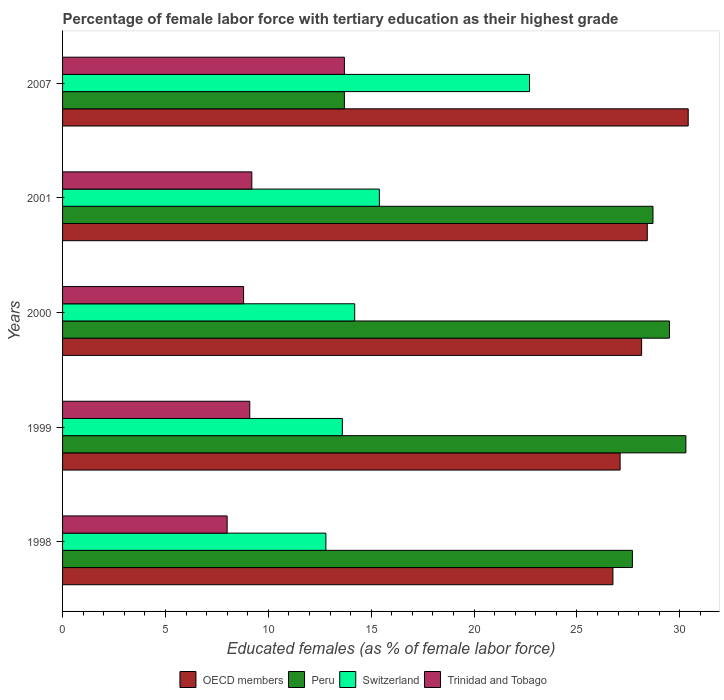How many different coloured bars are there?
Offer a very short reply. 4. How many groups of bars are there?
Give a very brief answer. 5. Are the number of bars per tick equal to the number of legend labels?
Your answer should be compact. Yes. How many bars are there on the 5th tick from the top?
Offer a terse response. 4. How many bars are there on the 3rd tick from the bottom?
Your response must be concise. 4. What is the label of the 2nd group of bars from the top?
Make the answer very short. 2001. What is the percentage of female labor force with tertiary education in Peru in 1998?
Provide a succinct answer. 27.7. Across all years, what is the maximum percentage of female labor force with tertiary education in OECD members?
Offer a very short reply. 30.41. Across all years, what is the minimum percentage of female labor force with tertiary education in Trinidad and Tobago?
Ensure brevity in your answer.  8. In which year was the percentage of female labor force with tertiary education in Peru maximum?
Ensure brevity in your answer.  1999. What is the total percentage of female labor force with tertiary education in Switzerland in the graph?
Make the answer very short. 78.7. What is the difference between the percentage of female labor force with tertiary education in Peru in 2000 and that in 2007?
Keep it short and to the point. 15.8. What is the difference between the percentage of female labor force with tertiary education in Peru in 1998 and the percentage of female labor force with tertiary education in Trinidad and Tobago in 2001?
Provide a succinct answer. 18.5. What is the average percentage of female labor force with tertiary education in Trinidad and Tobago per year?
Your response must be concise. 9.76. In the year 2007, what is the difference between the percentage of female labor force with tertiary education in Switzerland and percentage of female labor force with tertiary education in OECD members?
Provide a succinct answer. -7.71. What is the ratio of the percentage of female labor force with tertiary education in Switzerland in 1999 to that in 2007?
Keep it short and to the point. 0.6. Is the percentage of female labor force with tertiary education in Peru in 2000 less than that in 2001?
Make the answer very short. No. What is the difference between the highest and the second highest percentage of female labor force with tertiary education in Peru?
Provide a succinct answer. 0.8. What is the difference between the highest and the lowest percentage of female labor force with tertiary education in Trinidad and Tobago?
Offer a very short reply. 5.7. Is it the case that in every year, the sum of the percentage of female labor force with tertiary education in Trinidad and Tobago and percentage of female labor force with tertiary education in Switzerland is greater than the sum of percentage of female labor force with tertiary education in Peru and percentage of female labor force with tertiary education in OECD members?
Give a very brief answer. No. What does the 2nd bar from the top in 2001 represents?
Provide a short and direct response. Switzerland. What does the 3rd bar from the bottom in 2000 represents?
Keep it short and to the point. Switzerland. Is it the case that in every year, the sum of the percentage of female labor force with tertiary education in Switzerland and percentage of female labor force with tertiary education in Peru is greater than the percentage of female labor force with tertiary education in Trinidad and Tobago?
Offer a very short reply. Yes. Are all the bars in the graph horizontal?
Ensure brevity in your answer.  Yes. How many years are there in the graph?
Offer a terse response. 5. What is the difference between two consecutive major ticks on the X-axis?
Offer a very short reply. 5. Does the graph contain any zero values?
Your answer should be very brief. No. Where does the legend appear in the graph?
Provide a succinct answer. Bottom center. What is the title of the graph?
Ensure brevity in your answer.  Percentage of female labor force with tertiary education as their highest grade. Does "Mozambique" appear as one of the legend labels in the graph?
Make the answer very short. No. What is the label or title of the X-axis?
Your answer should be compact. Educated females (as % of female labor force). What is the Educated females (as % of female labor force) in OECD members in 1998?
Your answer should be very brief. 26.75. What is the Educated females (as % of female labor force) in Peru in 1998?
Your response must be concise. 27.7. What is the Educated females (as % of female labor force) of Switzerland in 1998?
Ensure brevity in your answer.  12.8. What is the Educated females (as % of female labor force) of Trinidad and Tobago in 1998?
Your response must be concise. 8. What is the Educated females (as % of female labor force) of OECD members in 1999?
Your response must be concise. 27.1. What is the Educated females (as % of female labor force) of Peru in 1999?
Offer a very short reply. 30.3. What is the Educated females (as % of female labor force) in Switzerland in 1999?
Provide a short and direct response. 13.6. What is the Educated females (as % of female labor force) of Trinidad and Tobago in 1999?
Provide a short and direct response. 9.1. What is the Educated females (as % of female labor force) in OECD members in 2000?
Give a very brief answer. 28.15. What is the Educated females (as % of female labor force) of Peru in 2000?
Provide a short and direct response. 29.5. What is the Educated females (as % of female labor force) of Switzerland in 2000?
Your answer should be very brief. 14.2. What is the Educated females (as % of female labor force) in Trinidad and Tobago in 2000?
Give a very brief answer. 8.8. What is the Educated females (as % of female labor force) in OECD members in 2001?
Your answer should be compact. 28.42. What is the Educated females (as % of female labor force) in Peru in 2001?
Offer a very short reply. 28.7. What is the Educated females (as % of female labor force) of Switzerland in 2001?
Offer a terse response. 15.4. What is the Educated females (as % of female labor force) in Trinidad and Tobago in 2001?
Provide a succinct answer. 9.2. What is the Educated females (as % of female labor force) of OECD members in 2007?
Keep it short and to the point. 30.41. What is the Educated females (as % of female labor force) of Peru in 2007?
Offer a very short reply. 13.7. What is the Educated females (as % of female labor force) in Switzerland in 2007?
Your answer should be very brief. 22.7. What is the Educated females (as % of female labor force) in Trinidad and Tobago in 2007?
Offer a very short reply. 13.7. Across all years, what is the maximum Educated females (as % of female labor force) in OECD members?
Your response must be concise. 30.41. Across all years, what is the maximum Educated females (as % of female labor force) of Peru?
Give a very brief answer. 30.3. Across all years, what is the maximum Educated females (as % of female labor force) in Switzerland?
Give a very brief answer. 22.7. Across all years, what is the maximum Educated females (as % of female labor force) in Trinidad and Tobago?
Offer a very short reply. 13.7. Across all years, what is the minimum Educated females (as % of female labor force) of OECD members?
Your answer should be very brief. 26.75. Across all years, what is the minimum Educated females (as % of female labor force) of Peru?
Your answer should be very brief. 13.7. Across all years, what is the minimum Educated females (as % of female labor force) of Switzerland?
Your answer should be compact. 12.8. Across all years, what is the minimum Educated females (as % of female labor force) of Trinidad and Tobago?
Make the answer very short. 8. What is the total Educated females (as % of female labor force) in OECD members in the graph?
Your response must be concise. 140.84. What is the total Educated females (as % of female labor force) of Peru in the graph?
Your answer should be very brief. 129.9. What is the total Educated females (as % of female labor force) in Switzerland in the graph?
Keep it short and to the point. 78.7. What is the total Educated females (as % of female labor force) of Trinidad and Tobago in the graph?
Give a very brief answer. 48.8. What is the difference between the Educated females (as % of female labor force) in OECD members in 1998 and that in 1999?
Give a very brief answer. -0.35. What is the difference between the Educated females (as % of female labor force) in Peru in 1998 and that in 1999?
Your answer should be very brief. -2.6. What is the difference between the Educated females (as % of female labor force) of Switzerland in 1998 and that in 1999?
Your answer should be compact. -0.8. What is the difference between the Educated females (as % of female labor force) in Trinidad and Tobago in 1998 and that in 1999?
Keep it short and to the point. -1.1. What is the difference between the Educated females (as % of female labor force) of OECD members in 1998 and that in 2000?
Your response must be concise. -1.4. What is the difference between the Educated females (as % of female labor force) of OECD members in 1998 and that in 2001?
Your response must be concise. -1.67. What is the difference between the Educated females (as % of female labor force) in Switzerland in 1998 and that in 2001?
Keep it short and to the point. -2.6. What is the difference between the Educated females (as % of female labor force) of OECD members in 1998 and that in 2007?
Keep it short and to the point. -3.66. What is the difference between the Educated females (as % of female labor force) in Peru in 1998 and that in 2007?
Provide a short and direct response. 14. What is the difference between the Educated females (as % of female labor force) in Switzerland in 1998 and that in 2007?
Offer a very short reply. -9.9. What is the difference between the Educated females (as % of female labor force) of OECD members in 1999 and that in 2000?
Keep it short and to the point. -1.05. What is the difference between the Educated females (as % of female labor force) of Peru in 1999 and that in 2000?
Provide a succinct answer. 0.8. What is the difference between the Educated females (as % of female labor force) of OECD members in 1999 and that in 2001?
Provide a short and direct response. -1.32. What is the difference between the Educated females (as % of female labor force) of OECD members in 1999 and that in 2007?
Give a very brief answer. -3.31. What is the difference between the Educated females (as % of female labor force) of Peru in 1999 and that in 2007?
Your response must be concise. 16.6. What is the difference between the Educated females (as % of female labor force) in Switzerland in 1999 and that in 2007?
Make the answer very short. -9.1. What is the difference between the Educated females (as % of female labor force) in OECD members in 2000 and that in 2001?
Offer a very short reply. -0.28. What is the difference between the Educated females (as % of female labor force) in Peru in 2000 and that in 2001?
Provide a short and direct response. 0.8. What is the difference between the Educated females (as % of female labor force) of Switzerland in 2000 and that in 2001?
Ensure brevity in your answer.  -1.2. What is the difference between the Educated females (as % of female labor force) of OECD members in 2000 and that in 2007?
Keep it short and to the point. -2.26. What is the difference between the Educated females (as % of female labor force) in Peru in 2000 and that in 2007?
Your answer should be very brief. 15.8. What is the difference between the Educated females (as % of female labor force) of Switzerland in 2000 and that in 2007?
Your response must be concise. -8.5. What is the difference between the Educated females (as % of female labor force) in OECD members in 2001 and that in 2007?
Provide a short and direct response. -1.99. What is the difference between the Educated females (as % of female labor force) of Peru in 2001 and that in 2007?
Provide a succinct answer. 15. What is the difference between the Educated females (as % of female labor force) of OECD members in 1998 and the Educated females (as % of female labor force) of Peru in 1999?
Your answer should be compact. -3.55. What is the difference between the Educated females (as % of female labor force) in OECD members in 1998 and the Educated females (as % of female labor force) in Switzerland in 1999?
Offer a terse response. 13.15. What is the difference between the Educated females (as % of female labor force) in OECD members in 1998 and the Educated females (as % of female labor force) in Trinidad and Tobago in 1999?
Your answer should be compact. 17.65. What is the difference between the Educated females (as % of female labor force) in Peru in 1998 and the Educated females (as % of female labor force) in Trinidad and Tobago in 1999?
Your response must be concise. 18.6. What is the difference between the Educated females (as % of female labor force) in OECD members in 1998 and the Educated females (as % of female labor force) in Peru in 2000?
Provide a short and direct response. -2.75. What is the difference between the Educated females (as % of female labor force) of OECD members in 1998 and the Educated females (as % of female labor force) of Switzerland in 2000?
Offer a terse response. 12.55. What is the difference between the Educated females (as % of female labor force) in OECD members in 1998 and the Educated females (as % of female labor force) in Trinidad and Tobago in 2000?
Your response must be concise. 17.95. What is the difference between the Educated females (as % of female labor force) in Peru in 1998 and the Educated females (as % of female labor force) in Switzerland in 2000?
Offer a terse response. 13.5. What is the difference between the Educated females (as % of female labor force) of Switzerland in 1998 and the Educated females (as % of female labor force) of Trinidad and Tobago in 2000?
Your response must be concise. 4. What is the difference between the Educated females (as % of female labor force) of OECD members in 1998 and the Educated females (as % of female labor force) of Peru in 2001?
Provide a succinct answer. -1.95. What is the difference between the Educated females (as % of female labor force) of OECD members in 1998 and the Educated females (as % of female labor force) of Switzerland in 2001?
Offer a very short reply. 11.35. What is the difference between the Educated females (as % of female labor force) of OECD members in 1998 and the Educated females (as % of female labor force) of Trinidad and Tobago in 2001?
Give a very brief answer. 17.55. What is the difference between the Educated females (as % of female labor force) of Peru in 1998 and the Educated females (as % of female labor force) of Switzerland in 2001?
Offer a terse response. 12.3. What is the difference between the Educated females (as % of female labor force) of Peru in 1998 and the Educated females (as % of female labor force) of Trinidad and Tobago in 2001?
Ensure brevity in your answer.  18.5. What is the difference between the Educated females (as % of female labor force) in Switzerland in 1998 and the Educated females (as % of female labor force) in Trinidad and Tobago in 2001?
Give a very brief answer. 3.6. What is the difference between the Educated females (as % of female labor force) of OECD members in 1998 and the Educated females (as % of female labor force) of Peru in 2007?
Give a very brief answer. 13.05. What is the difference between the Educated females (as % of female labor force) of OECD members in 1998 and the Educated females (as % of female labor force) of Switzerland in 2007?
Keep it short and to the point. 4.05. What is the difference between the Educated females (as % of female labor force) in OECD members in 1998 and the Educated females (as % of female labor force) in Trinidad and Tobago in 2007?
Keep it short and to the point. 13.05. What is the difference between the Educated females (as % of female labor force) of OECD members in 1999 and the Educated females (as % of female labor force) of Peru in 2000?
Ensure brevity in your answer.  -2.4. What is the difference between the Educated females (as % of female labor force) of OECD members in 1999 and the Educated females (as % of female labor force) of Switzerland in 2000?
Give a very brief answer. 12.9. What is the difference between the Educated females (as % of female labor force) in OECD members in 1999 and the Educated females (as % of female labor force) in Trinidad and Tobago in 2000?
Offer a very short reply. 18.3. What is the difference between the Educated females (as % of female labor force) in Peru in 1999 and the Educated females (as % of female labor force) in Switzerland in 2000?
Ensure brevity in your answer.  16.1. What is the difference between the Educated females (as % of female labor force) of OECD members in 1999 and the Educated females (as % of female labor force) of Peru in 2001?
Ensure brevity in your answer.  -1.6. What is the difference between the Educated females (as % of female labor force) in OECD members in 1999 and the Educated females (as % of female labor force) in Switzerland in 2001?
Keep it short and to the point. 11.7. What is the difference between the Educated females (as % of female labor force) in OECD members in 1999 and the Educated females (as % of female labor force) in Trinidad and Tobago in 2001?
Your answer should be compact. 17.9. What is the difference between the Educated females (as % of female labor force) of Peru in 1999 and the Educated females (as % of female labor force) of Switzerland in 2001?
Keep it short and to the point. 14.9. What is the difference between the Educated females (as % of female labor force) in Peru in 1999 and the Educated females (as % of female labor force) in Trinidad and Tobago in 2001?
Give a very brief answer. 21.1. What is the difference between the Educated females (as % of female labor force) in Switzerland in 1999 and the Educated females (as % of female labor force) in Trinidad and Tobago in 2001?
Offer a very short reply. 4.4. What is the difference between the Educated females (as % of female labor force) in OECD members in 1999 and the Educated females (as % of female labor force) in Peru in 2007?
Provide a short and direct response. 13.4. What is the difference between the Educated females (as % of female labor force) of OECD members in 1999 and the Educated females (as % of female labor force) of Switzerland in 2007?
Offer a very short reply. 4.4. What is the difference between the Educated females (as % of female labor force) in OECD members in 1999 and the Educated females (as % of female labor force) in Trinidad and Tobago in 2007?
Give a very brief answer. 13.4. What is the difference between the Educated females (as % of female labor force) in Peru in 1999 and the Educated females (as % of female labor force) in Switzerland in 2007?
Offer a very short reply. 7.6. What is the difference between the Educated females (as % of female labor force) in Peru in 1999 and the Educated females (as % of female labor force) in Trinidad and Tobago in 2007?
Provide a short and direct response. 16.6. What is the difference between the Educated females (as % of female labor force) in OECD members in 2000 and the Educated females (as % of female labor force) in Peru in 2001?
Provide a short and direct response. -0.55. What is the difference between the Educated females (as % of female labor force) in OECD members in 2000 and the Educated females (as % of female labor force) in Switzerland in 2001?
Keep it short and to the point. 12.75. What is the difference between the Educated females (as % of female labor force) of OECD members in 2000 and the Educated females (as % of female labor force) of Trinidad and Tobago in 2001?
Make the answer very short. 18.95. What is the difference between the Educated females (as % of female labor force) in Peru in 2000 and the Educated females (as % of female labor force) in Trinidad and Tobago in 2001?
Your answer should be compact. 20.3. What is the difference between the Educated females (as % of female labor force) in Switzerland in 2000 and the Educated females (as % of female labor force) in Trinidad and Tobago in 2001?
Ensure brevity in your answer.  5. What is the difference between the Educated females (as % of female labor force) in OECD members in 2000 and the Educated females (as % of female labor force) in Peru in 2007?
Provide a short and direct response. 14.45. What is the difference between the Educated females (as % of female labor force) of OECD members in 2000 and the Educated females (as % of female labor force) of Switzerland in 2007?
Give a very brief answer. 5.45. What is the difference between the Educated females (as % of female labor force) of OECD members in 2000 and the Educated females (as % of female labor force) of Trinidad and Tobago in 2007?
Your answer should be very brief. 14.45. What is the difference between the Educated females (as % of female labor force) in Peru in 2000 and the Educated females (as % of female labor force) in Trinidad and Tobago in 2007?
Offer a terse response. 15.8. What is the difference between the Educated females (as % of female labor force) in OECD members in 2001 and the Educated females (as % of female labor force) in Peru in 2007?
Your response must be concise. 14.72. What is the difference between the Educated females (as % of female labor force) in OECD members in 2001 and the Educated females (as % of female labor force) in Switzerland in 2007?
Provide a succinct answer. 5.72. What is the difference between the Educated females (as % of female labor force) of OECD members in 2001 and the Educated females (as % of female labor force) of Trinidad and Tobago in 2007?
Offer a terse response. 14.72. What is the difference between the Educated females (as % of female labor force) in Peru in 2001 and the Educated females (as % of female labor force) in Trinidad and Tobago in 2007?
Keep it short and to the point. 15. What is the difference between the Educated females (as % of female labor force) in Switzerland in 2001 and the Educated females (as % of female labor force) in Trinidad and Tobago in 2007?
Provide a short and direct response. 1.7. What is the average Educated females (as % of female labor force) in OECD members per year?
Provide a succinct answer. 28.17. What is the average Educated females (as % of female labor force) of Peru per year?
Ensure brevity in your answer.  25.98. What is the average Educated females (as % of female labor force) of Switzerland per year?
Your response must be concise. 15.74. What is the average Educated females (as % of female labor force) of Trinidad and Tobago per year?
Your answer should be compact. 9.76. In the year 1998, what is the difference between the Educated females (as % of female labor force) of OECD members and Educated females (as % of female labor force) of Peru?
Your response must be concise. -0.95. In the year 1998, what is the difference between the Educated females (as % of female labor force) of OECD members and Educated females (as % of female labor force) of Switzerland?
Your response must be concise. 13.95. In the year 1998, what is the difference between the Educated females (as % of female labor force) of OECD members and Educated females (as % of female labor force) of Trinidad and Tobago?
Offer a very short reply. 18.75. In the year 1999, what is the difference between the Educated females (as % of female labor force) in OECD members and Educated females (as % of female labor force) in Peru?
Your answer should be compact. -3.2. In the year 1999, what is the difference between the Educated females (as % of female labor force) of OECD members and Educated females (as % of female labor force) of Switzerland?
Make the answer very short. 13.5. In the year 1999, what is the difference between the Educated females (as % of female labor force) of OECD members and Educated females (as % of female labor force) of Trinidad and Tobago?
Offer a terse response. 18. In the year 1999, what is the difference between the Educated females (as % of female labor force) in Peru and Educated females (as % of female labor force) in Trinidad and Tobago?
Make the answer very short. 21.2. In the year 2000, what is the difference between the Educated females (as % of female labor force) of OECD members and Educated females (as % of female labor force) of Peru?
Offer a terse response. -1.35. In the year 2000, what is the difference between the Educated females (as % of female labor force) of OECD members and Educated females (as % of female labor force) of Switzerland?
Provide a short and direct response. 13.95. In the year 2000, what is the difference between the Educated females (as % of female labor force) in OECD members and Educated females (as % of female labor force) in Trinidad and Tobago?
Offer a very short reply. 19.35. In the year 2000, what is the difference between the Educated females (as % of female labor force) of Peru and Educated females (as % of female labor force) of Trinidad and Tobago?
Provide a succinct answer. 20.7. In the year 2001, what is the difference between the Educated females (as % of female labor force) of OECD members and Educated females (as % of female labor force) of Peru?
Provide a succinct answer. -0.28. In the year 2001, what is the difference between the Educated females (as % of female labor force) of OECD members and Educated females (as % of female labor force) of Switzerland?
Provide a short and direct response. 13.02. In the year 2001, what is the difference between the Educated females (as % of female labor force) of OECD members and Educated females (as % of female labor force) of Trinidad and Tobago?
Make the answer very short. 19.22. In the year 2007, what is the difference between the Educated females (as % of female labor force) of OECD members and Educated females (as % of female labor force) of Peru?
Provide a succinct answer. 16.71. In the year 2007, what is the difference between the Educated females (as % of female labor force) in OECD members and Educated females (as % of female labor force) in Switzerland?
Ensure brevity in your answer.  7.71. In the year 2007, what is the difference between the Educated females (as % of female labor force) in OECD members and Educated females (as % of female labor force) in Trinidad and Tobago?
Ensure brevity in your answer.  16.71. What is the ratio of the Educated females (as % of female labor force) of OECD members in 1998 to that in 1999?
Offer a terse response. 0.99. What is the ratio of the Educated females (as % of female labor force) in Peru in 1998 to that in 1999?
Keep it short and to the point. 0.91. What is the ratio of the Educated females (as % of female labor force) of Trinidad and Tobago in 1998 to that in 1999?
Offer a terse response. 0.88. What is the ratio of the Educated females (as % of female labor force) in OECD members in 1998 to that in 2000?
Make the answer very short. 0.95. What is the ratio of the Educated females (as % of female labor force) in Peru in 1998 to that in 2000?
Your answer should be compact. 0.94. What is the ratio of the Educated females (as % of female labor force) of Switzerland in 1998 to that in 2000?
Offer a terse response. 0.9. What is the ratio of the Educated females (as % of female labor force) in Trinidad and Tobago in 1998 to that in 2000?
Give a very brief answer. 0.91. What is the ratio of the Educated females (as % of female labor force) in OECD members in 1998 to that in 2001?
Make the answer very short. 0.94. What is the ratio of the Educated females (as % of female labor force) in Peru in 1998 to that in 2001?
Offer a very short reply. 0.97. What is the ratio of the Educated females (as % of female labor force) of Switzerland in 1998 to that in 2001?
Ensure brevity in your answer.  0.83. What is the ratio of the Educated females (as % of female labor force) in Trinidad and Tobago in 1998 to that in 2001?
Make the answer very short. 0.87. What is the ratio of the Educated females (as % of female labor force) of OECD members in 1998 to that in 2007?
Provide a succinct answer. 0.88. What is the ratio of the Educated females (as % of female labor force) of Peru in 1998 to that in 2007?
Keep it short and to the point. 2.02. What is the ratio of the Educated females (as % of female labor force) of Switzerland in 1998 to that in 2007?
Give a very brief answer. 0.56. What is the ratio of the Educated females (as % of female labor force) in Trinidad and Tobago in 1998 to that in 2007?
Give a very brief answer. 0.58. What is the ratio of the Educated females (as % of female labor force) in OECD members in 1999 to that in 2000?
Offer a terse response. 0.96. What is the ratio of the Educated females (as % of female labor force) in Peru in 1999 to that in 2000?
Your answer should be compact. 1.03. What is the ratio of the Educated females (as % of female labor force) in Switzerland in 1999 to that in 2000?
Provide a short and direct response. 0.96. What is the ratio of the Educated females (as % of female labor force) in Trinidad and Tobago in 1999 to that in 2000?
Provide a succinct answer. 1.03. What is the ratio of the Educated females (as % of female labor force) in OECD members in 1999 to that in 2001?
Your response must be concise. 0.95. What is the ratio of the Educated females (as % of female labor force) of Peru in 1999 to that in 2001?
Keep it short and to the point. 1.06. What is the ratio of the Educated females (as % of female labor force) of Switzerland in 1999 to that in 2001?
Provide a succinct answer. 0.88. What is the ratio of the Educated females (as % of female labor force) in Trinidad and Tobago in 1999 to that in 2001?
Provide a short and direct response. 0.99. What is the ratio of the Educated females (as % of female labor force) in OECD members in 1999 to that in 2007?
Provide a short and direct response. 0.89. What is the ratio of the Educated females (as % of female labor force) in Peru in 1999 to that in 2007?
Provide a short and direct response. 2.21. What is the ratio of the Educated females (as % of female labor force) of Switzerland in 1999 to that in 2007?
Offer a terse response. 0.6. What is the ratio of the Educated females (as % of female labor force) of Trinidad and Tobago in 1999 to that in 2007?
Make the answer very short. 0.66. What is the ratio of the Educated females (as % of female labor force) in OECD members in 2000 to that in 2001?
Give a very brief answer. 0.99. What is the ratio of the Educated females (as % of female labor force) in Peru in 2000 to that in 2001?
Keep it short and to the point. 1.03. What is the ratio of the Educated females (as % of female labor force) of Switzerland in 2000 to that in 2001?
Provide a succinct answer. 0.92. What is the ratio of the Educated females (as % of female labor force) in Trinidad and Tobago in 2000 to that in 2001?
Give a very brief answer. 0.96. What is the ratio of the Educated females (as % of female labor force) in OECD members in 2000 to that in 2007?
Your answer should be very brief. 0.93. What is the ratio of the Educated females (as % of female labor force) in Peru in 2000 to that in 2007?
Give a very brief answer. 2.15. What is the ratio of the Educated females (as % of female labor force) in Switzerland in 2000 to that in 2007?
Your answer should be compact. 0.63. What is the ratio of the Educated females (as % of female labor force) in Trinidad and Tobago in 2000 to that in 2007?
Your answer should be very brief. 0.64. What is the ratio of the Educated females (as % of female labor force) in OECD members in 2001 to that in 2007?
Provide a succinct answer. 0.93. What is the ratio of the Educated females (as % of female labor force) of Peru in 2001 to that in 2007?
Provide a succinct answer. 2.09. What is the ratio of the Educated females (as % of female labor force) in Switzerland in 2001 to that in 2007?
Make the answer very short. 0.68. What is the ratio of the Educated females (as % of female labor force) in Trinidad and Tobago in 2001 to that in 2007?
Your answer should be compact. 0.67. What is the difference between the highest and the second highest Educated females (as % of female labor force) in OECD members?
Provide a short and direct response. 1.99. What is the difference between the highest and the second highest Educated females (as % of female labor force) in Peru?
Make the answer very short. 0.8. What is the difference between the highest and the second highest Educated females (as % of female labor force) in Switzerland?
Your answer should be compact. 7.3. What is the difference between the highest and the lowest Educated females (as % of female labor force) in OECD members?
Keep it short and to the point. 3.66. What is the difference between the highest and the lowest Educated females (as % of female labor force) in Switzerland?
Give a very brief answer. 9.9. 